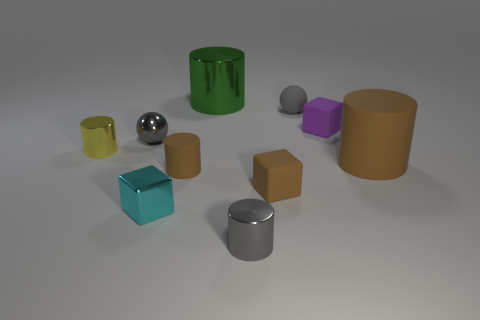Subtract all brown matte cubes. How many cubes are left? 2 Subtract all brown spheres. How many brown cylinders are left? 2 Subtract 1 blocks. How many blocks are left? 2 Subtract all gray cylinders. How many cylinders are left? 4 Subtract all spheres. How many objects are left? 8 Subtract all gray blocks. Subtract all brown cylinders. How many blocks are left? 3 Subtract all small gray cylinders. Subtract all large green shiny things. How many objects are left? 8 Add 2 blocks. How many blocks are left? 5 Add 1 big yellow matte spheres. How many big yellow matte spheres exist? 1 Subtract 0 blue cylinders. How many objects are left? 10 